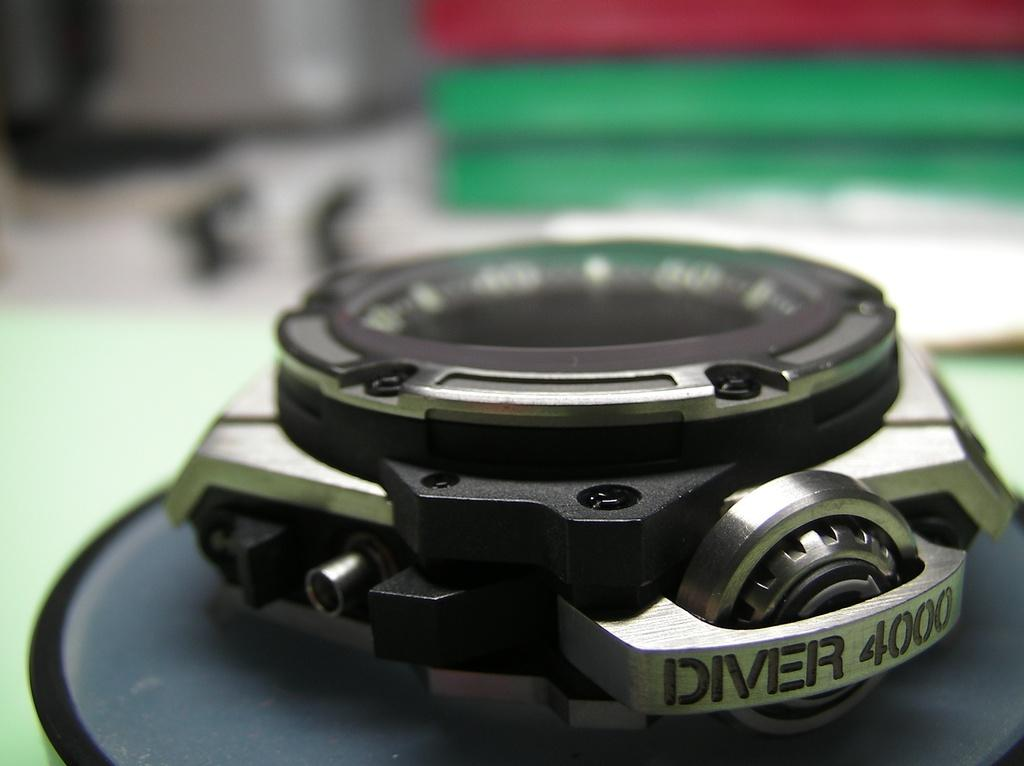What is the main subject of the image? The main subject of the image is the dial of a watch. Where is the dial of the watch located? The dial of the watch is on a table. What type of ball can be seen being used for a haircut in the image? There is no ball or haircut present in the image; it only features the dial of a watch on a table. 